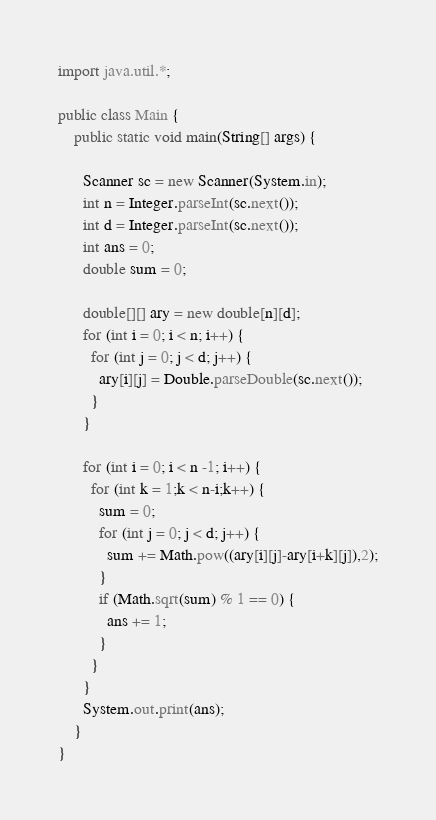<code> <loc_0><loc_0><loc_500><loc_500><_Java_>import java.util.*;

public class Main {
    public static void main(String[] args) {
      
      Scanner sc = new Scanner(System.in);
      int n = Integer.parseInt(sc.next());
      int d = Integer.parseInt(sc.next());
      int ans = 0;
      double sum = 0;
      
      double[][] ary = new double[n][d];
      for (int i = 0; i < n; i++) {
        for (int j = 0; j < d; j++) {
          ary[i][j] = Double.parseDouble(sc.next());
        }
      }
      
      for (int i = 0; i < n -1; i++) {
        for (int k = 1;k < n-i;k++) {
          sum = 0;
          for (int j = 0; j < d; j++) {
            sum += Math.pow((ary[i][j]-ary[i+k][j]),2);
          }
          if (Math.sqrt(sum) % 1 == 0) {
            ans += 1;
          }
        }
      }
      System.out.print(ans);
    }
}

</code> 